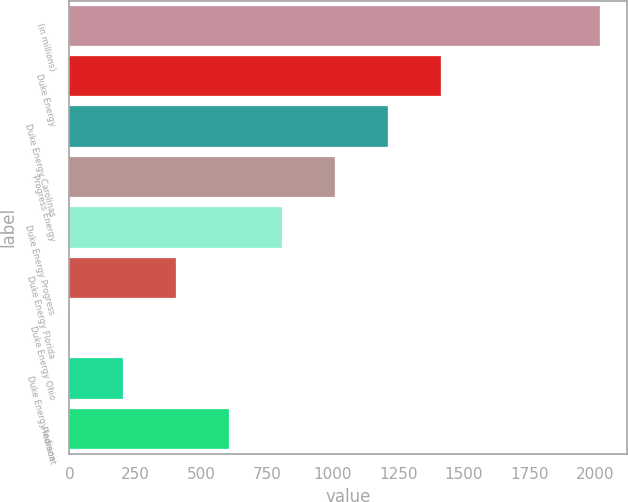Convert chart. <chart><loc_0><loc_0><loc_500><loc_500><bar_chart><fcel>(in millions)<fcel>Duke Energy<fcel>Duke Energy Carolinas<fcel>Progress Energy<fcel>Duke Energy Progress<fcel>Duke Energy Florida<fcel>Duke Energy Ohio<fcel>Duke Energy Indiana<fcel>Piedmont<nl><fcel>2017<fcel>1413.1<fcel>1211.8<fcel>1010.5<fcel>809.2<fcel>406.6<fcel>4<fcel>205.3<fcel>607.9<nl></chart> 